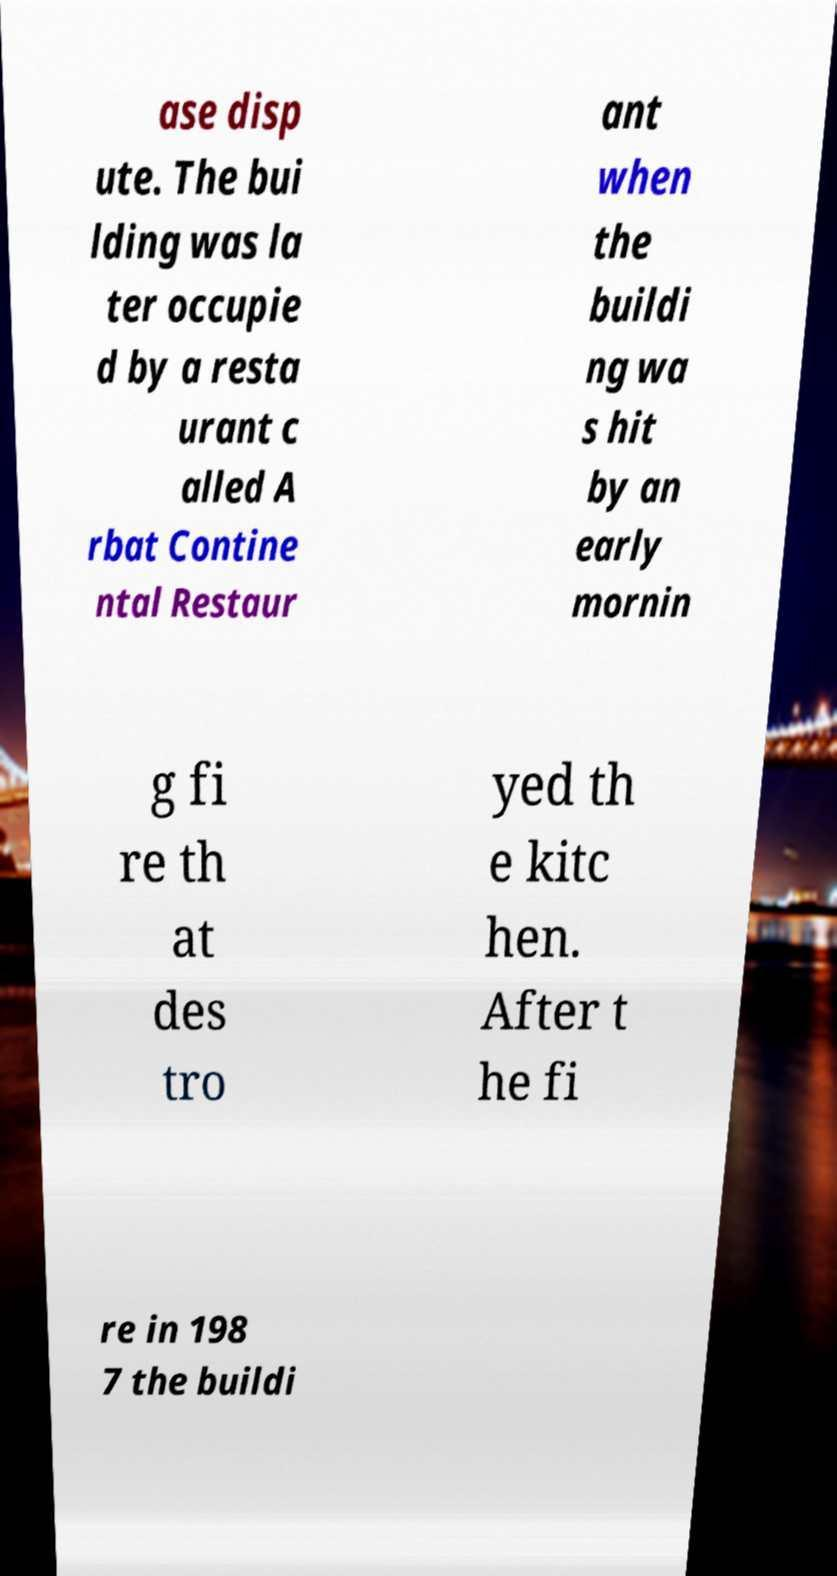Can you read and provide the text displayed in the image?This photo seems to have some interesting text. Can you extract and type it out for me? ase disp ute. The bui lding was la ter occupie d by a resta urant c alled A rbat Contine ntal Restaur ant when the buildi ng wa s hit by an early mornin g fi re th at des tro yed th e kitc hen. After t he fi re in 198 7 the buildi 